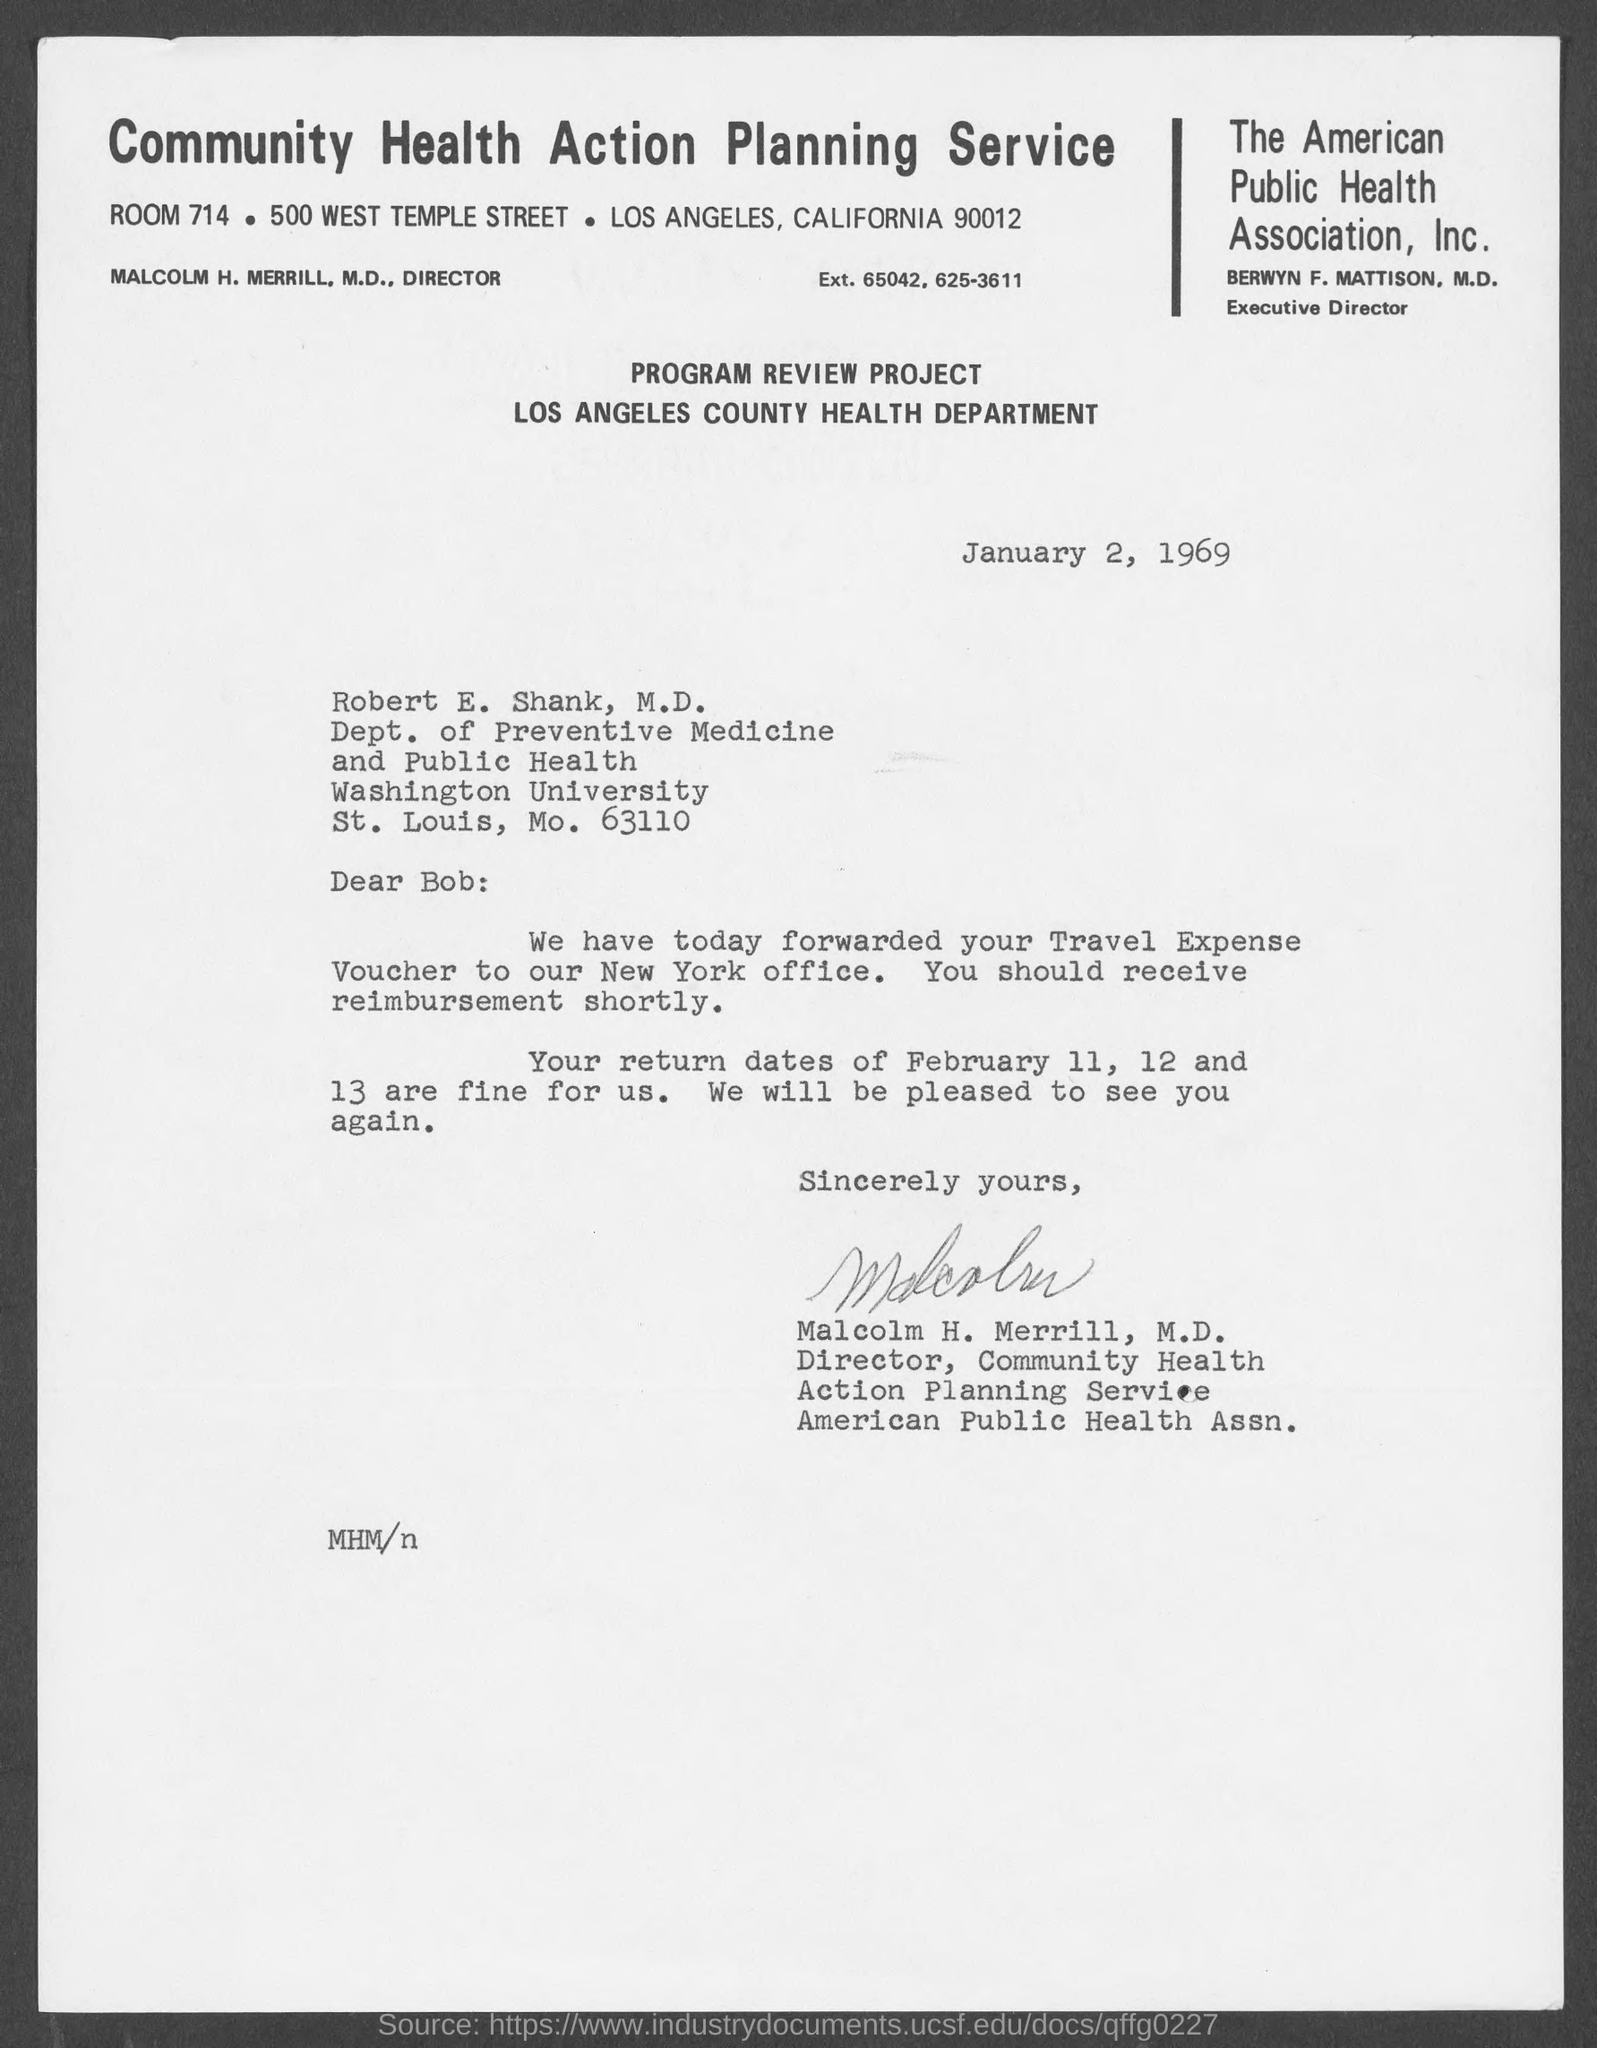What is the date mentioned ?
Your answer should be compact. January 2, 1969. Who is the executive director of the american public health association inc
Offer a terse response. Berwyn F. Mattison. What is the room no or room mentioned ?
Provide a short and direct response. 714. To whom this letter is written ?
Make the answer very short. Robert E. Shank. To which department robert e. shank belongs to ?
Your answer should be very brief. Dept. of Preventive Medicine and Public Health. To which university robert e. shank belongs to
Make the answer very short. Washington University. This letter is written by whom ?
Provide a short and direct response. Malcolm H. Merrill, M.D. Who is the director of community health action planning service ?
Ensure brevity in your answer.  Malcolm H. Merrill. 